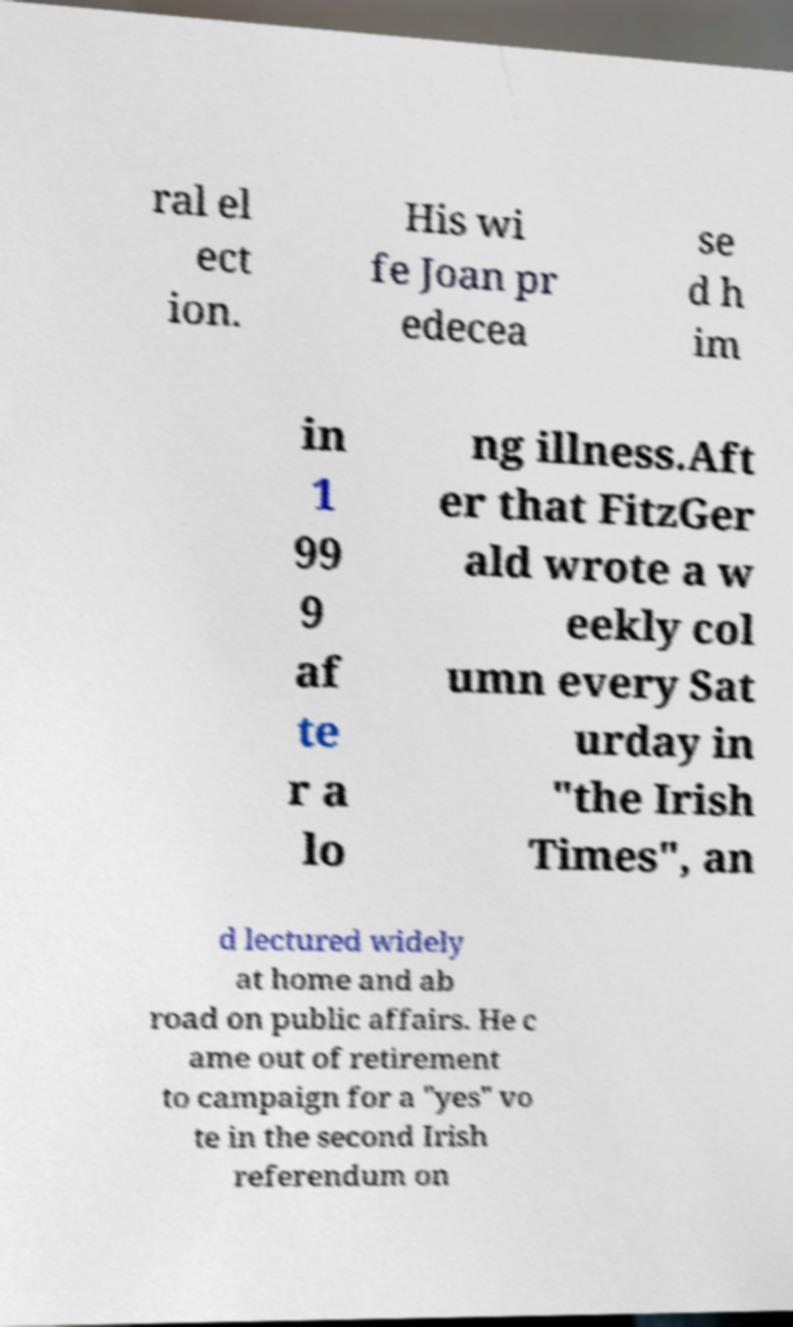Please identify and transcribe the text found in this image. ral el ect ion. His wi fe Joan pr edecea se d h im in 1 99 9 af te r a lo ng illness.Aft er that FitzGer ald wrote a w eekly col umn every Sat urday in "the Irish Times", an d lectured widely at home and ab road on public affairs. He c ame out of retirement to campaign for a "yes" vo te in the second Irish referendum on 